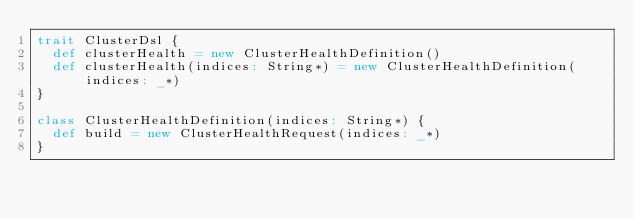Convert code to text. <code><loc_0><loc_0><loc_500><loc_500><_Scala_>trait ClusterDsl {
  def clusterHealth = new ClusterHealthDefinition()
  def clusterHealth(indices: String*) = new ClusterHealthDefinition(indices: _*)
}

class ClusterHealthDefinition(indices: String*) {
  def build = new ClusterHealthRequest(indices: _*)
}
</code> 